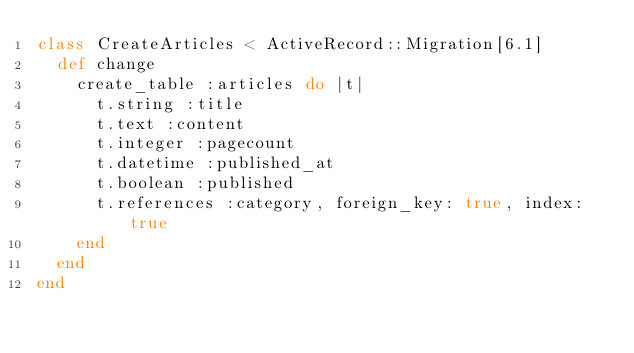Convert code to text. <code><loc_0><loc_0><loc_500><loc_500><_Ruby_>class CreateArticles < ActiveRecord::Migration[6.1]
  def change
    create_table :articles do |t|
      t.string :title
      t.text :content
      t.integer :pagecount
      t.datetime :published_at
      t.boolean :published
      t.references :category, foreign_key: true, index: true
    end
  end
end
</code> 